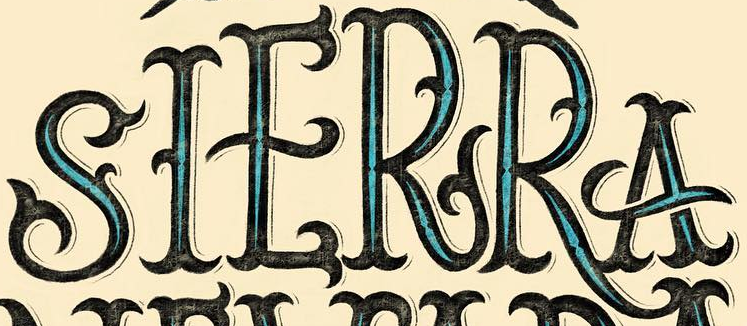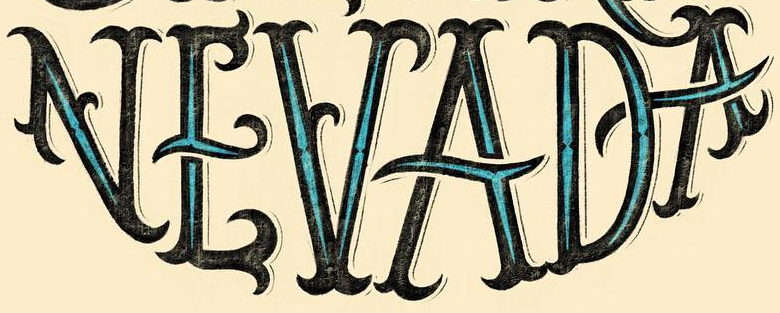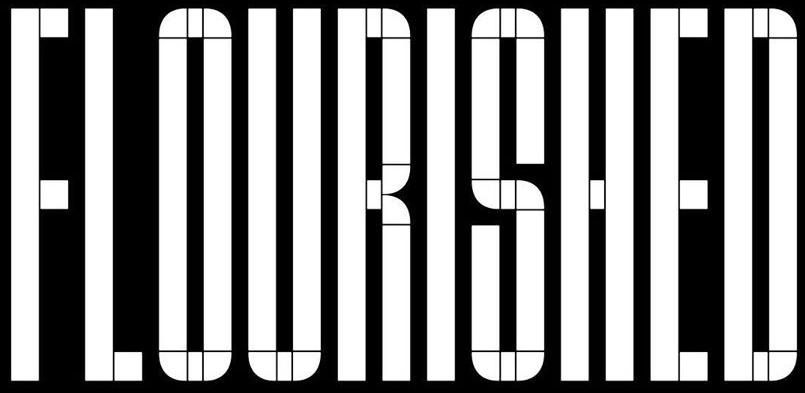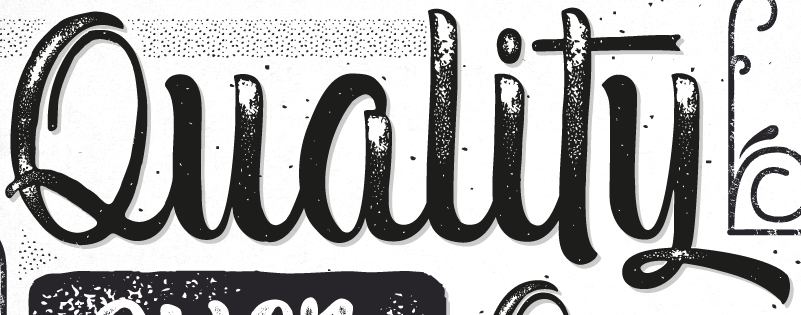Read the text content from these images in order, separated by a semicolon. SIERRA; NEVADA; FLOURISHED; Quality 